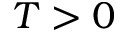Convert formula to latex. <formula><loc_0><loc_0><loc_500><loc_500>T > 0</formula> 